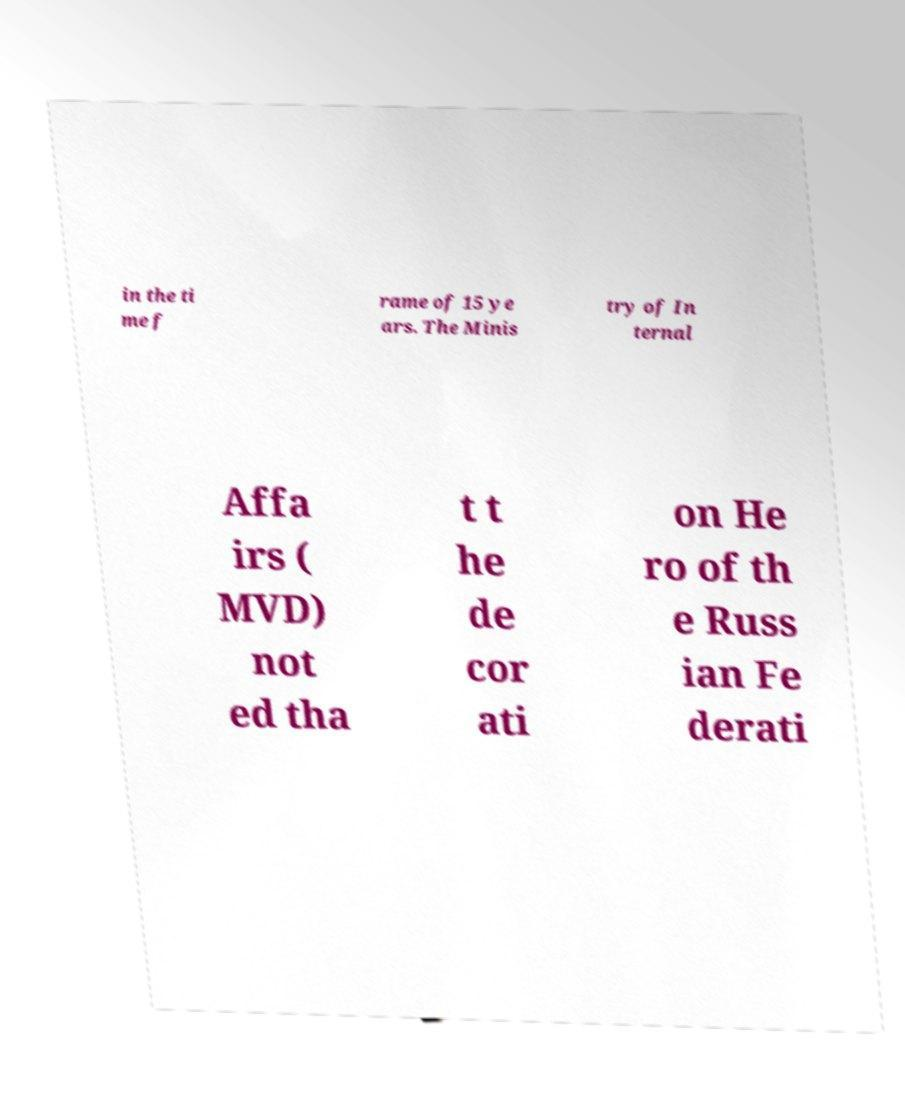For documentation purposes, I need the text within this image transcribed. Could you provide that? in the ti me f rame of 15 ye ars. The Minis try of In ternal Affa irs ( MVD) not ed tha t t he de cor ati on He ro of th e Russ ian Fe derati 